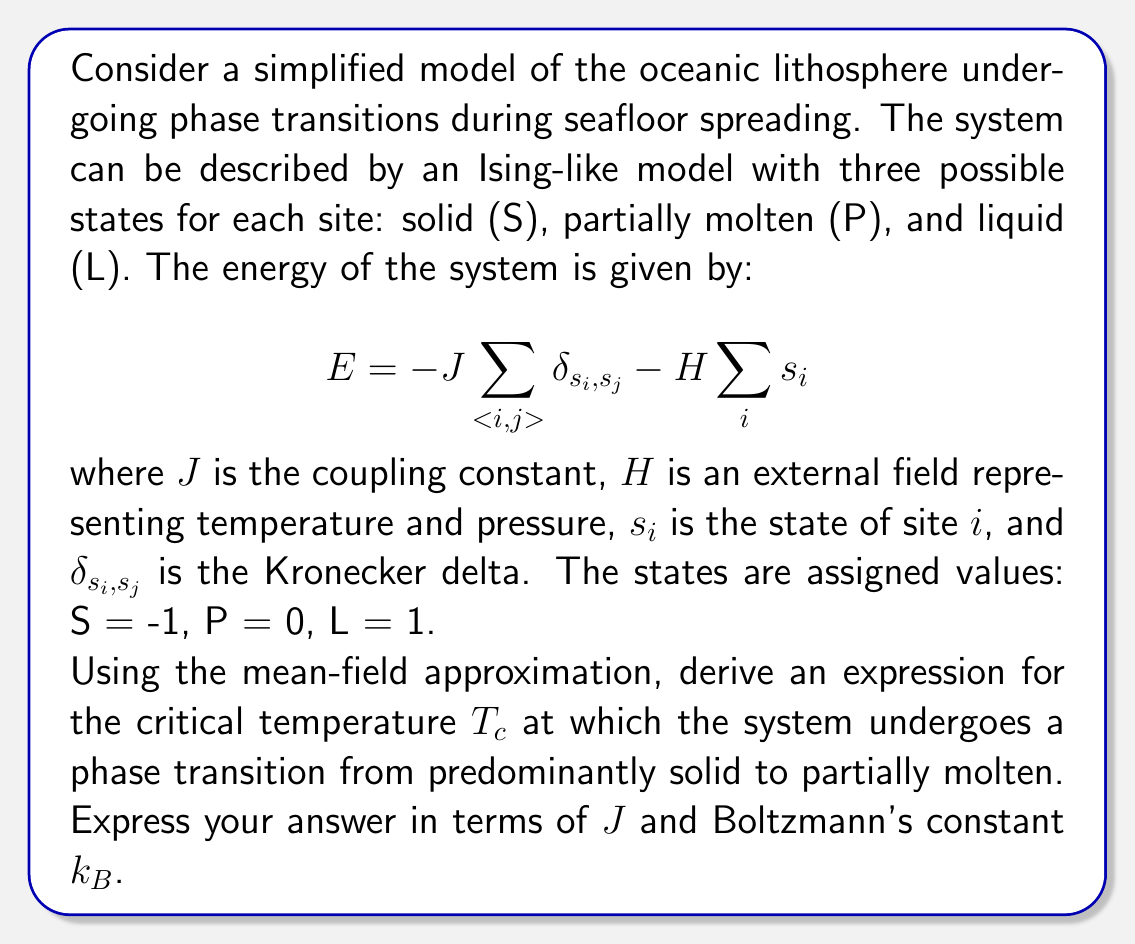Could you help me with this problem? To solve this problem, we'll use the mean-field approximation and follow these steps:

1) In the mean-field approximation, we assume that each site interacts with an average field produced by its neighbors. Let's define the average state (or magnetization) as $m = \langle s_i \rangle$.

2) The effective field experienced by each site is:

   $$h_{eff} = zJm + H$$

   where $z$ is the number of nearest neighbors.

3) The probability of a site being in each state is given by the Boltzmann distribution:

   $$P(s_i) = \frac{e^{-\beta E_{s_i}}}{\sum_{s} e^{-\beta E_s}}$$

   where $\beta = \frac{1}{k_B T}$ and $E_{s_i} = -s_i h_{eff}$.

4) The average state can be calculated as:

   $$m = \langle s_i \rangle = \sum_{s} s P(s)$$

5) Substituting the probabilities:

   $$m = \frac{-1 \cdot e^{\beta h_{eff}} + 0 \cdot 1 + 1 \cdot e^{-\beta h_{eff}}}{e^{\beta h_{eff}} + 1 + e^{-\beta h_{eff}}}$$

6) This can be simplified to:

   $$m = \tanh(\beta h_{eff}) = \tanh(\beta(zJm + H))$$

7) At the critical temperature and in the absence of external field ($H = 0$), this equation has a non-zero solution for $m$ that appears continuously from zero. This occurs when the slope of $\tanh(\beta zJm)$ at $m = 0$ is equal to 1:

   $$\left.\frac{d}{dm}\tanh(\beta zJm)\right|_{m=0} = \beta zJ = 1$$

8) Solving for the critical temperature:

   $$T_c = \frac{zJ}{k_B}$$

This expression gives the critical temperature in terms of $J$ and $k_B$, as requested.
Answer: $T_c = \frac{zJ}{k_B}$ 